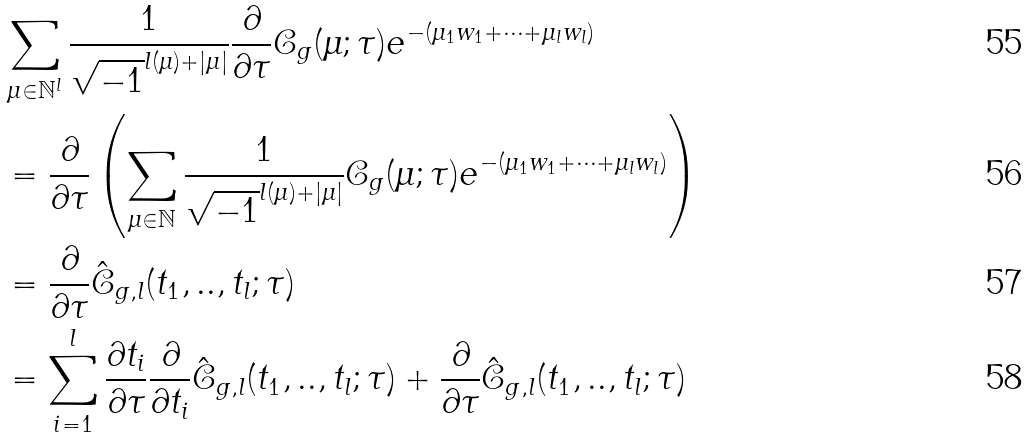Convert formula to latex. <formula><loc_0><loc_0><loc_500><loc_500>& \sum _ { \mu \in \mathbb { N } ^ { l } } \frac { 1 } { \sqrt { - 1 } ^ { l ( \mu ) + | \mu | } } \frac { \partial } { \partial \tau } \mathcal { C } _ { g } ( \mu ; \tau ) e ^ { - ( \mu _ { 1 } w _ { 1 } + \cdots + \mu _ { l } w _ { l } ) } \\ & = \frac { \partial } { \partial \tau } \left ( \sum _ { \mu \in \mathbb { N } } \frac { 1 } { \sqrt { - 1 } ^ { l ( \mu ) + | \mu | } } \mathcal { C } _ { g } ( \mu ; \tau ) e ^ { - ( \mu _ { 1 } w _ { 1 } + \cdots + \mu _ { l } w _ { l } ) } \right ) \\ & = \frac { \partial } { \partial \tau } \hat { \mathcal { C } } _ { g , l } ( t _ { 1 } , . . , t _ { l } ; \tau ) \\ & = \sum _ { i = 1 } ^ { l } \frac { \partial t _ { i } } { \partial \tau } \frac { \partial } { \partial t _ { i } } \hat { \mathcal { C } } _ { g , l } ( t _ { 1 } , . . , t _ { l } ; \tau ) + \frac { \partial } { \partial \tau } \hat { \mathcal { C } } _ { g , l } ( t _ { 1 } , . . , t _ { l } ; \tau )</formula> 